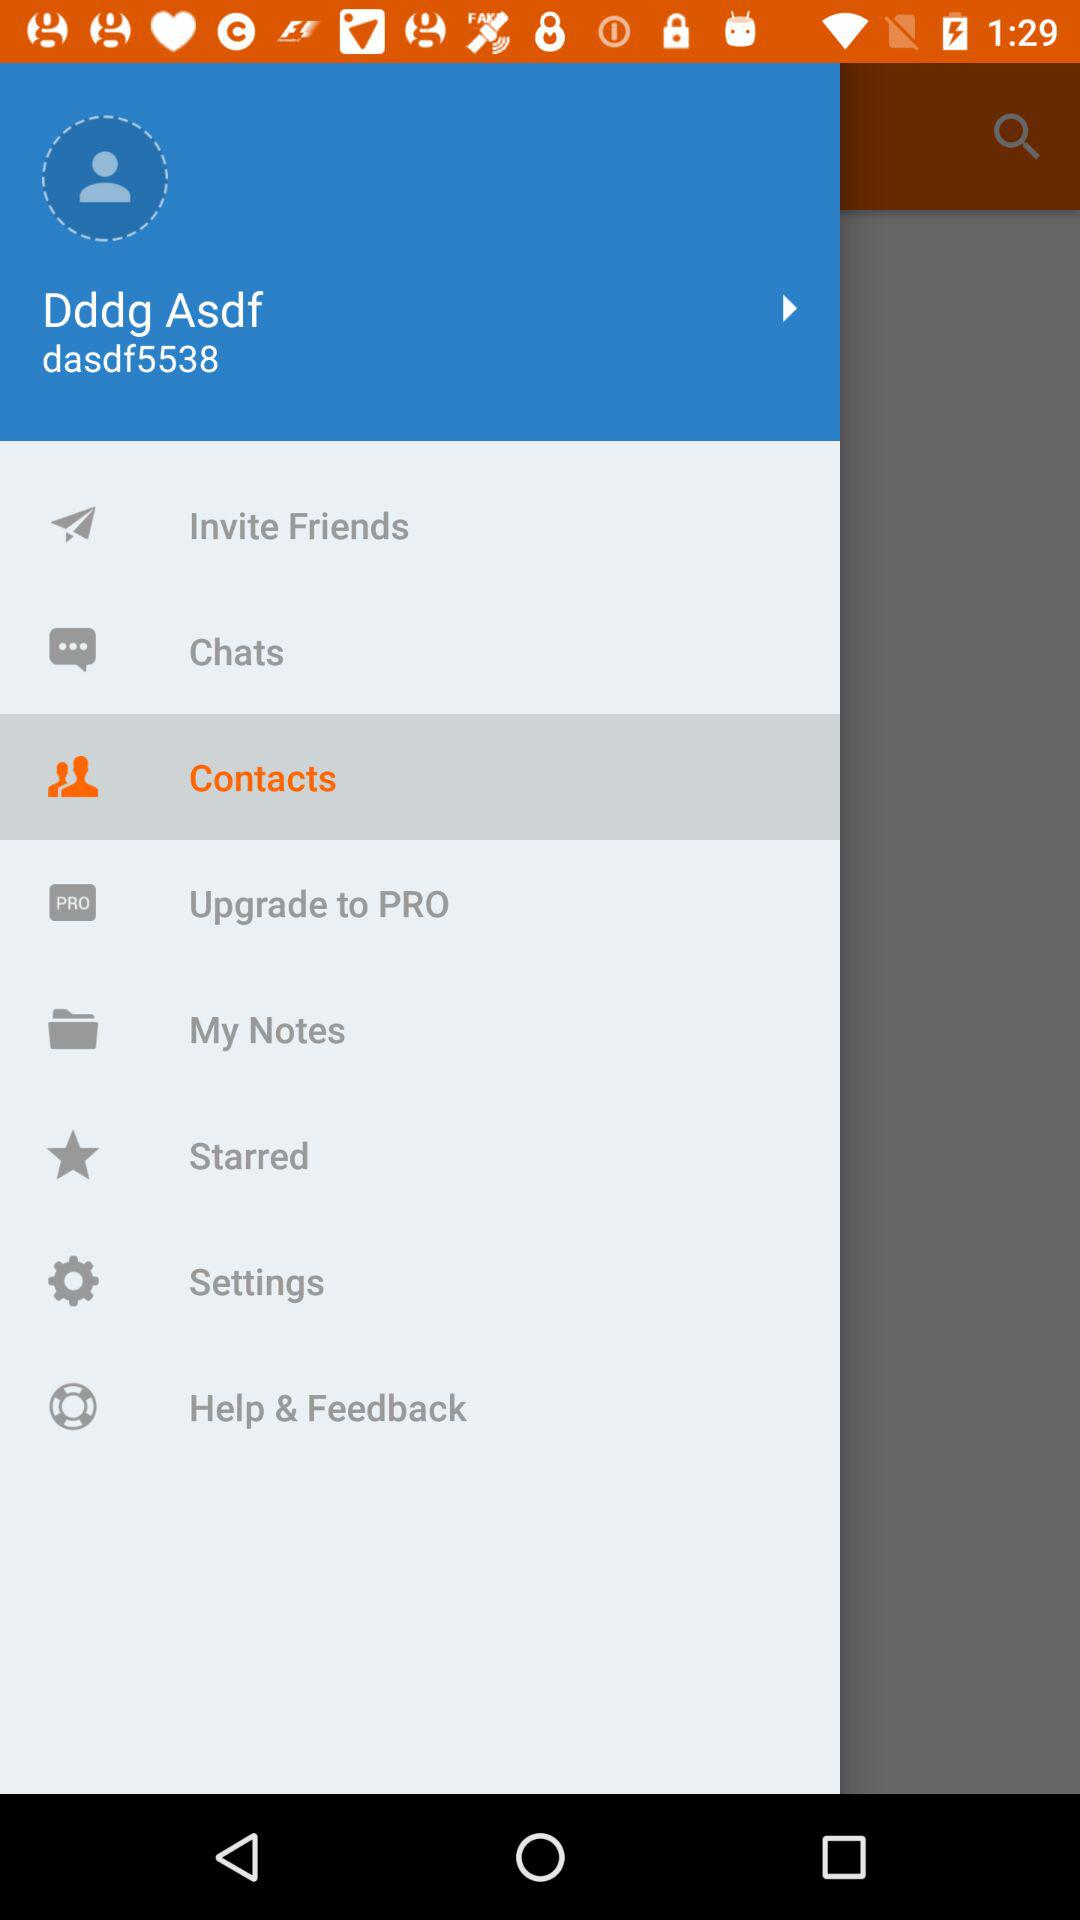What is the user name? The user name is Dddg Asdf. 